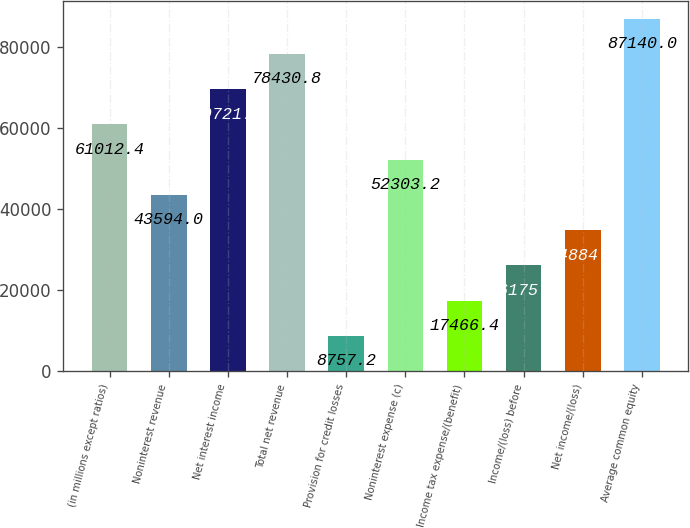Convert chart. <chart><loc_0><loc_0><loc_500><loc_500><bar_chart><fcel>(in millions except ratios)<fcel>Noninterest revenue<fcel>Net interest income<fcel>Total net revenue<fcel>Provision for credit losses<fcel>Noninterest expense (c)<fcel>Income tax expense/(benefit)<fcel>Income/(loss) before<fcel>Net income/(loss)<fcel>Average common equity<nl><fcel>61012.4<fcel>43594<fcel>69721.6<fcel>78430.8<fcel>8757.2<fcel>52303.2<fcel>17466.4<fcel>26175.6<fcel>34884.8<fcel>87140<nl></chart> 